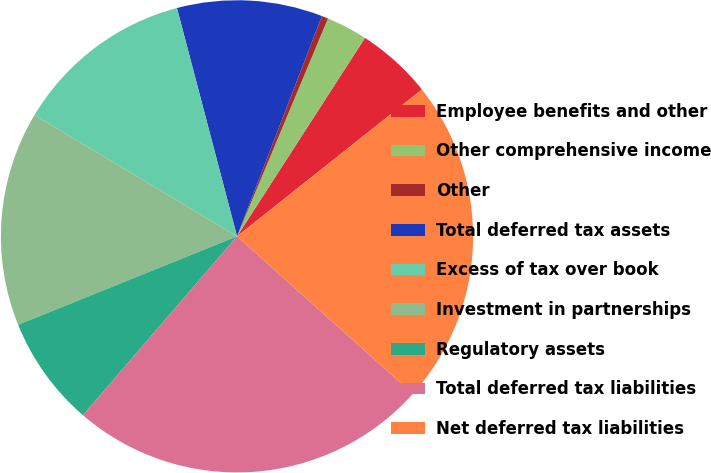<chart> <loc_0><loc_0><loc_500><loc_500><pie_chart><fcel>Employee benefits and other<fcel>Other comprehensive income<fcel>Other<fcel>Total deferred tax assets<fcel>Excess of tax over book<fcel>Investment in partnerships<fcel>Regulatory assets<fcel>Total deferred tax liabilities<fcel>Net deferred tax liabilities<nl><fcel>5.2%<fcel>2.82%<fcel>0.44%<fcel>9.95%<fcel>12.32%<fcel>14.7%<fcel>7.57%<fcel>24.69%<fcel>22.31%<nl></chart> 